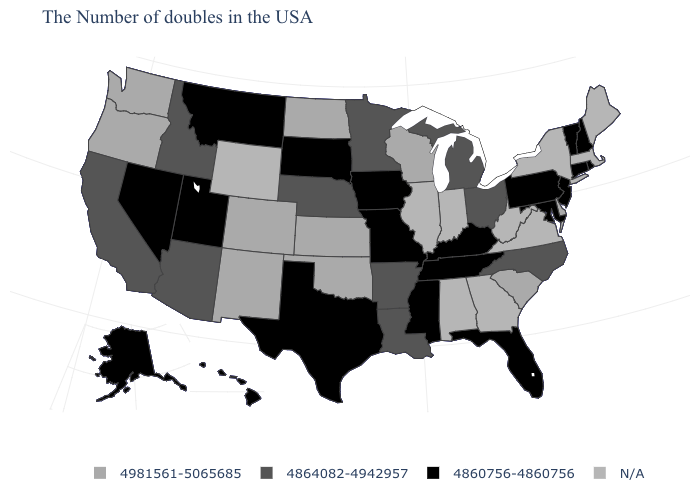What is the value of Alabama?
Answer briefly. N/A. What is the lowest value in states that border New Hampshire?
Quick response, please. 4860756-4860756. Name the states that have a value in the range 4864082-4942957?
Concise answer only. North Carolina, Ohio, Michigan, Louisiana, Arkansas, Minnesota, Nebraska, Arizona, Idaho, California. Name the states that have a value in the range 4981561-5065685?
Keep it brief. Delaware, South Carolina, Wisconsin, Kansas, Oklahoma, North Dakota, Colorado, New Mexico, Washington, Oregon. What is the lowest value in states that border Georgia?
Keep it brief. 4860756-4860756. What is the value of Kentucky?
Keep it brief. 4860756-4860756. What is the highest value in states that border Minnesota?
Short answer required. 4981561-5065685. Name the states that have a value in the range 4864082-4942957?
Answer briefly. North Carolina, Ohio, Michigan, Louisiana, Arkansas, Minnesota, Nebraska, Arizona, Idaho, California. What is the lowest value in states that border Tennessee?
Be succinct. 4860756-4860756. Which states have the highest value in the USA?
Keep it brief. Delaware, South Carolina, Wisconsin, Kansas, Oklahoma, North Dakota, Colorado, New Mexico, Washington, Oregon. Does the map have missing data?
Answer briefly. Yes. Name the states that have a value in the range 4864082-4942957?
Give a very brief answer. North Carolina, Ohio, Michigan, Louisiana, Arkansas, Minnesota, Nebraska, Arizona, Idaho, California. What is the value of Utah?
Answer briefly. 4860756-4860756. What is the value of Nevada?
Quick response, please. 4860756-4860756. 